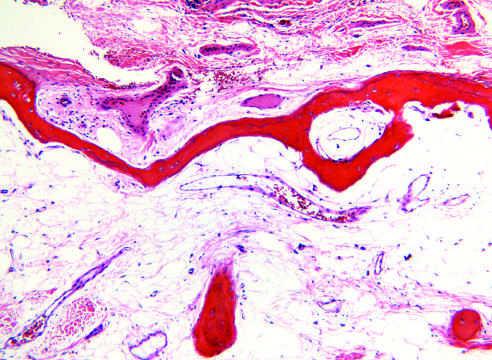re the trabecular bone of the medulla and the cortical bone markedly thinned?
Answer the question using a single word or phrase. Yes 